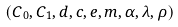<formula> <loc_0><loc_0><loc_500><loc_500>\left ( C _ { 0 } , C _ { 1 } , d , c , e , m , \alpha , \lambda , \rho \right )</formula> 